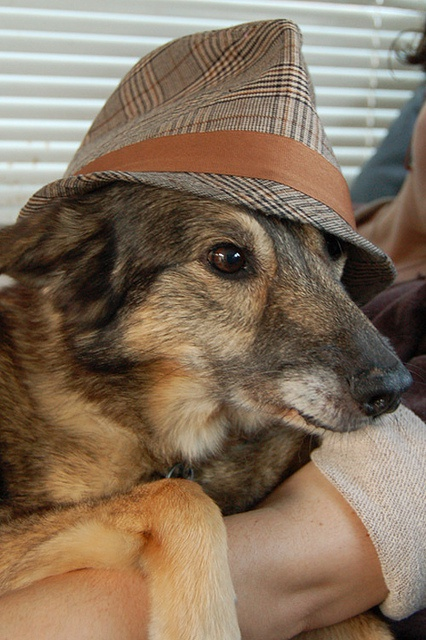Describe the objects in this image and their specific colors. I can see dog in lightgray, black, maroon, and gray tones and people in lightgray, gray, darkgray, and tan tones in this image. 